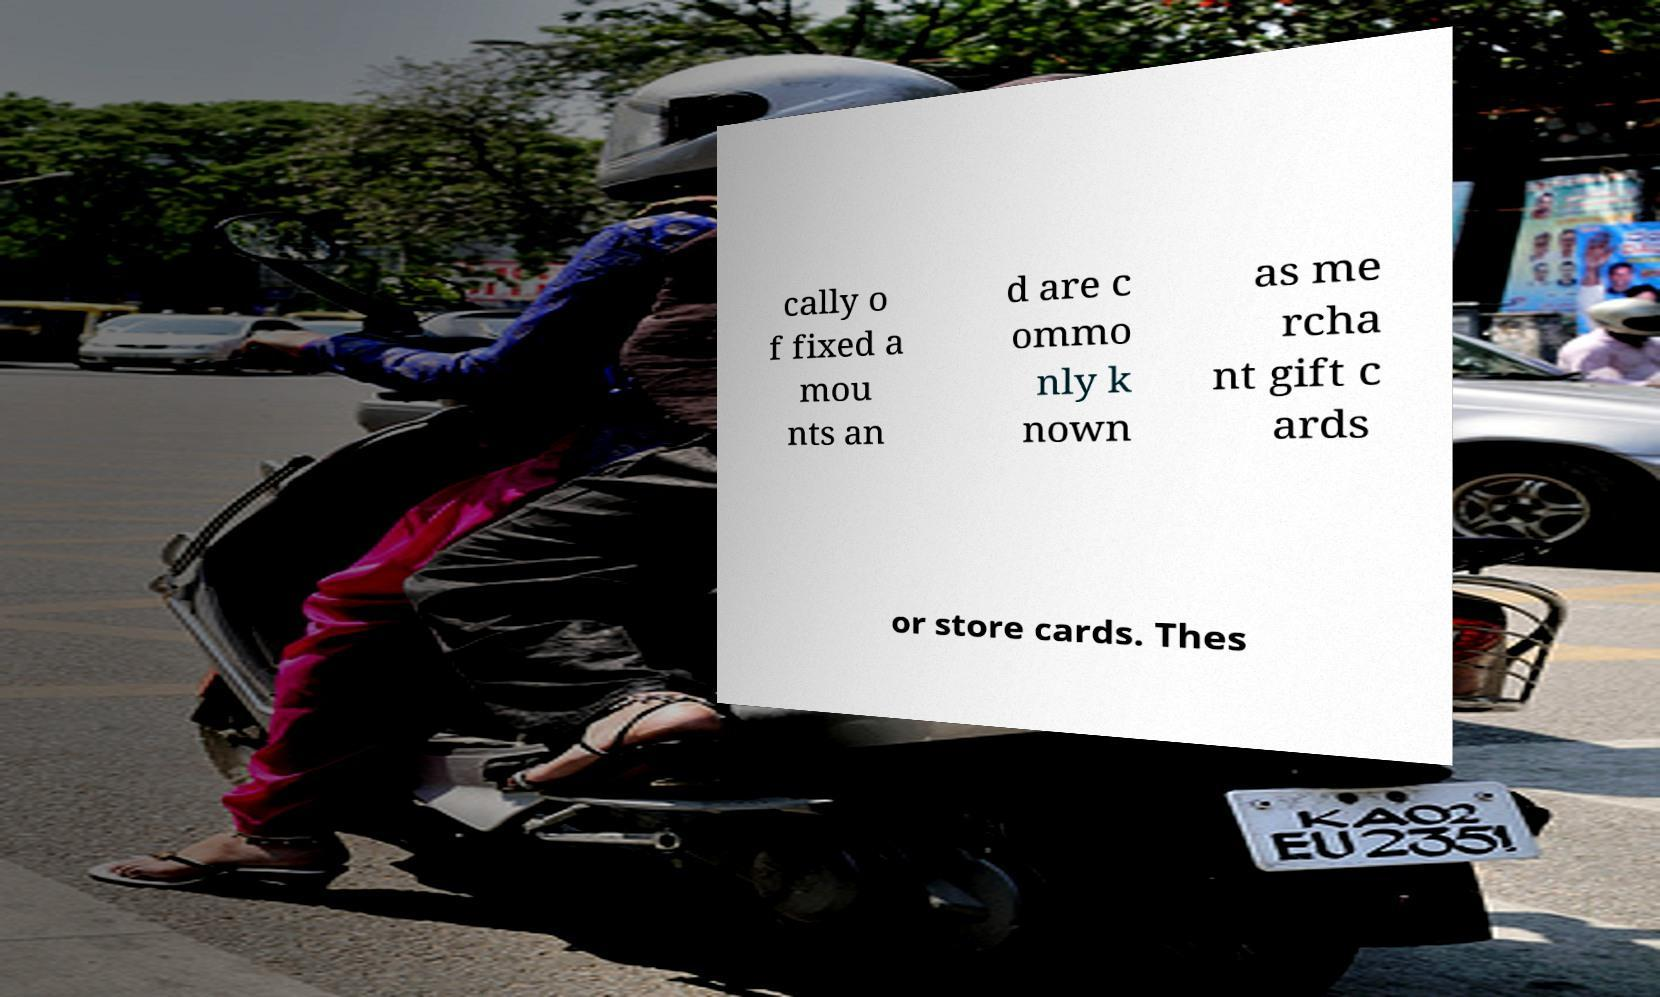Can you accurately transcribe the text from the provided image for me? cally o f fixed a mou nts an d are c ommo nly k nown as me rcha nt gift c ards or store cards. Thes 